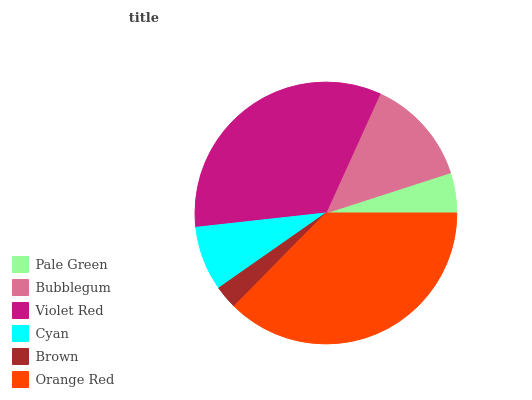Is Brown the minimum?
Answer yes or no. Yes. Is Orange Red the maximum?
Answer yes or no. Yes. Is Bubblegum the minimum?
Answer yes or no. No. Is Bubblegum the maximum?
Answer yes or no. No. Is Bubblegum greater than Pale Green?
Answer yes or no. Yes. Is Pale Green less than Bubblegum?
Answer yes or no. Yes. Is Pale Green greater than Bubblegum?
Answer yes or no. No. Is Bubblegum less than Pale Green?
Answer yes or no. No. Is Bubblegum the high median?
Answer yes or no. Yes. Is Cyan the low median?
Answer yes or no. Yes. Is Orange Red the high median?
Answer yes or no. No. Is Violet Red the low median?
Answer yes or no. No. 